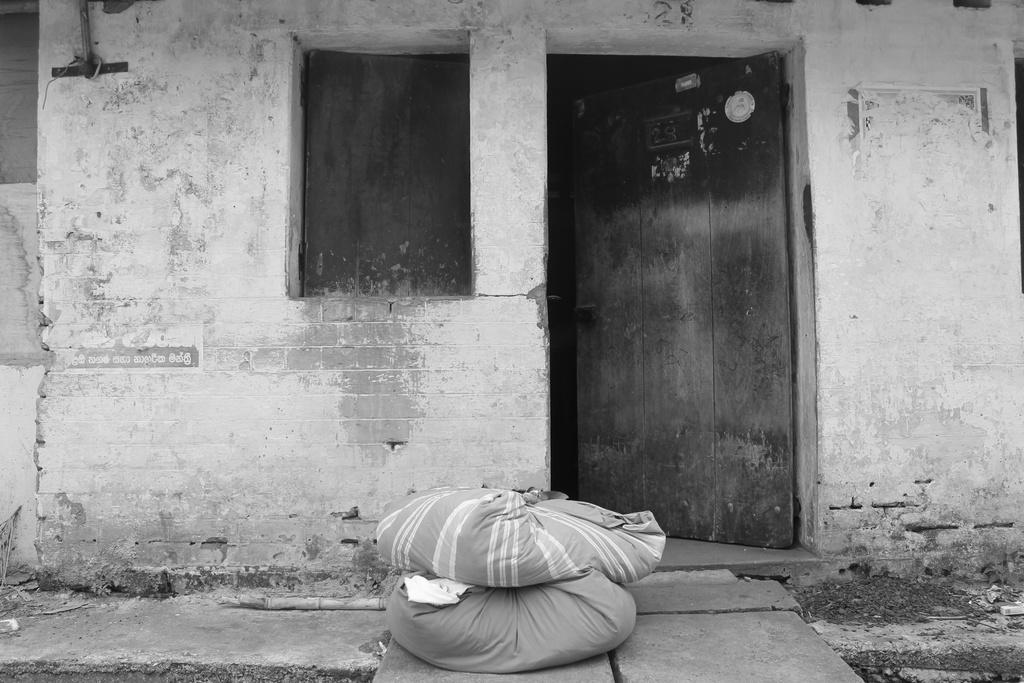What type of photo is in the image? The image contains a black and white photo. What is the subject of the photo? The photo depicts a house wall. Are there any openings in the house wall? Yes, there is a door and a window in the photo. What else can be seen at the bottom of the photo? Two cloth sacks are visible in the front bottom side of the photo. What type of rice is being represented in the photo? There is no rice present in the photo; it depicts a house wall with a door, window, and cloth sacks. 